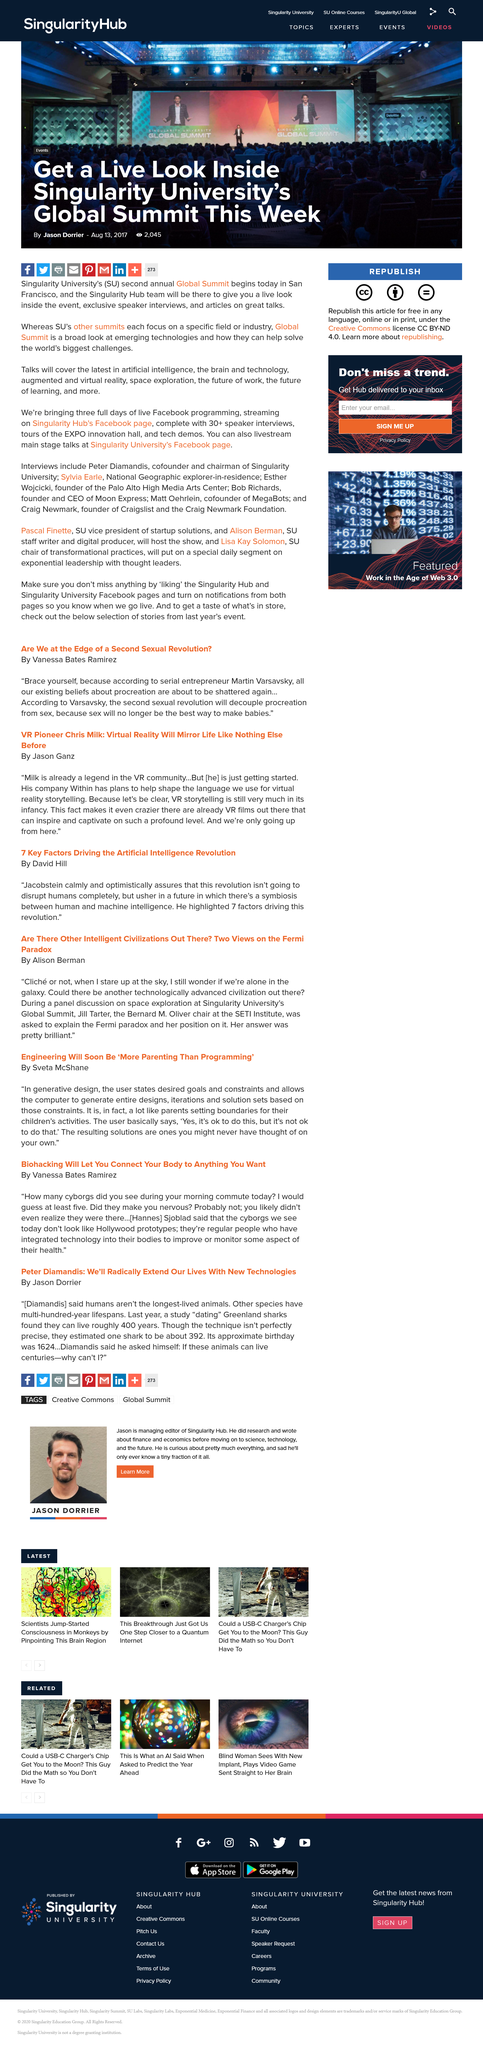Specify some key components in this picture. This article has been viewed by 2045 individuals and shared 273 times on various media platforms. The scientist asked himself what is the reason for human beings to live as long as other species, and why we are capable of doing so. VR storytelling, in its infancy, is a promising and evolving field that holds significant potential for the future of digital content creation and consumption. It is not the first time they are attending the Global Summit, as it is their second time, The event takes place in San Francisco. 